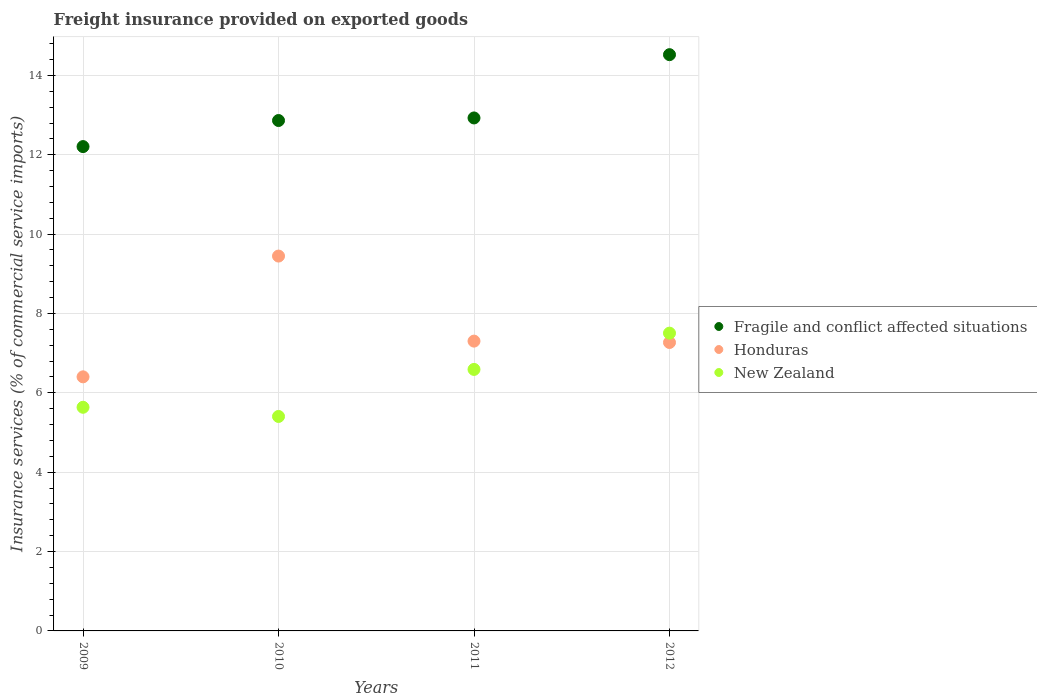Is the number of dotlines equal to the number of legend labels?
Give a very brief answer. Yes. What is the freight insurance provided on exported goods in Fragile and conflict affected situations in 2009?
Your response must be concise. 12.21. Across all years, what is the maximum freight insurance provided on exported goods in Honduras?
Provide a succinct answer. 9.45. Across all years, what is the minimum freight insurance provided on exported goods in New Zealand?
Give a very brief answer. 5.4. In which year was the freight insurance provided on exported goods in Fragile and conflict affected situations minimum?
Make the answer very short. 2009. What is the total freight insurance provided on exported goods in Honduras in the graph?
Your response must be concise. 30.42. What is the difference between the freight insurance provided on exported goods in New Zealand in 2009 and that in 2012?
Your answer should be very brief. -1.87. What is the difference between the freight insurance provided on exported goods in Fragile and conflict affected situations in 2011 and the freight insurance provided on exported goods in Honduras in 2012?
Give a very brief answer. 5.66. What is the average freight insurance provided on exported goods in Fragile and conflict affected situations per year?
Your answer should be very brief. 13.13. In the year 2009, what is the difference between the freight insurance provided on exported goods in New Zealand and freight insurance provided on exported goods in Fragile and conflict affected situations?
Offer a terse response. -6.57. What is the ratio of the freight insurance provided on exported goods in Fragile and conflict affected situations in 2009 to that in 2012?
Your answer should be compact. 0.84. Is the freight insurance provided on exported goods in Honduras in 2009 less than that in 2012?
Provide a short and direct response. Yes. Is the difference between the freight insurance provided on exported goods in New Zealand in 2010 and 2012 greater than the difference between the freight insurance provided on exported goods in Fragile and conflict affected situations in 2010 and 2012?
Offer a terse response. No. What is the difference between the highest and the second highest freight insurance provided on exported goods in Fragile and conflict affected situations?
Keep it short and to the point. 1.59. What is the difference between the highest and the lowest freight insurance provided on exported goods in Fragile and conflict affected situations?
Offer a very short reply. 2.32. Is the sum of the freight insurance provided on exported goods in Honduras in 2010 and 2011 greater than the maximum freight insurance provided on exported goods in Fragile and conflict affected situations across all years?
Your response must be concise. Yes. Does the freight insurance provided on exported goods in New Zealand monotonically increase over the years?
Offer a terse response. No. Is the freight insurance provided on exported goods in New Zealand strictly greater than the freight insurance provided on exported goods in Fragile and conflict affected situations over the years?
Your answer should be compact. No. How many dotlines are there?
Offer a terse response. 3. How many years are there in the graph?
Ensure brevity in your answer.  4. Are the values on the major ticks of Y-axis written in scientific E-notation?
Provide a short and direct response. No. Does the graph contain any zero values?
Give a very brief answer. No. Does the graph contain grids?
Your response must be concise. Yes. Where does the legend appear in the graph?
Your answer should be very brief. Center right. What is the title of the graph?
Offer a terse response. Freight insurance provided on exported goods. Does "Myanmar" appear as one of the legend labels in the graph?
Ensure brevity in your answer.  No. What is the label or title of the X-axis?
Keep it short and to the point. Years. What is the label or title of the Y-axis?
Provide a succinct answer. Insurance services (% of commercial service imports). What is the Insurance services (% of commercial service imports) of Fragile and conflict affected situations in 2009?
Offer a terse response. 12.21. What is the Insurance services (% of commercial service imports) in Honduras in 2009?
Your answer should be very brief. 6.4. What is the Insurance services (% of commercial service imports) of New Zealand in 2009?
Offer a very short reply. 5.64. What is the Insurance services (% of commercial service imports) in Fragile and conflict affected situations in 2010?
Your answer should be compact. 12.86. What is the Insurance services (% of commercial service imports) of Honduras in 2010?
Provide a succinct answer. 9.45. What is the Insurance services (% of commercial service imports) of New Zealand in 2010?
Your answer should be very brief. 5.4. What is the Insurance services (% of commercial service imports) in Fragile and conflict affected situations in 2011?
Your answer should be very brief. 12.93. What is the Insurance services (% of commercial service imports) in Honduras in 2011?
Offer a terse response. 7.3. What is the Insurance services (% of commercial service imports) in New Zealand in 2011?
Provide a short and direct response. 6.59. What is the Insurance services (% of commercial service imports) of Fragile and conflict affected situations in 2012?
Your answer should be compact. 14.52. What is the Insurance services (% of commercial service imports) in Honduras in 2012?
Keep it short and to the point. 7.27. What is the Insurance services (% of commercial service imports) of New Zealand in 2012?
Give a very brief answer. 7.5. Across all years, what is the maximum Insurance services (% of commercial service imports) of Fragile and conflict affected situations?
Your answer should be very brief. 14.52. Across all years, what is the maximum Insurance services (% of commercial service imports) in Honduras?
Make the answer very short. 9.45. Across all years, what is the maximum Insurance services (% of commercial service imports) of New Zealand?
Provide a short and direct response. 7.5. Across all years, what is the minimum Insurance services (% of commercial service imports) in Fragile and conflict affected situations?
Provide a short and direct response. 12.21. Across all years, what is the minimum Insurance services (% of commercial service imports) in Honduras?
Ensure brevity in your answer.  6.4. Across all years, what is the minimum Insurance services (% of commercial service imports) in New Zealand?
Your answer should be compact. 5.4. What is the total Insurance services (% of commercial service imports) in Fragile and conflict affected situations in the graph?
Give a very brief answer. 52.52. What is the total Insurance services (% of commercial service imports) in Honduras in the graph?
Provide a short and direct response. 30.42. What is the total Insurance services (% of commercial service imports) in New Zealand in the graph?
Provide a short and direct response. 25.14. What is the difference between the Insurance services (% of commercial service imports) in Fragile and conflict affected situations in 2009 and that in 2010?
Your answer should be compact. -0.66. What is the difference between the Insurance services (% of commercial service imports) in Honduras in 2009 and that in 2010?
Give a very brief answer. -3.04. What is the difference between the Insurance services (% of commercial service imports) in New Zealand in 2009 and that in 2010?
Your response must be concise. 0.23. What is the difference between the Insurance services (% of commercial service imports) in Fragile and conflict affected situations in 2009 and that in 2011?
Ensure brevity in your answer.  -0.72. What is the difference between the Insurance services (% of commercial service imports) of Honduras in 2009 and that in 2011?
Keep it short and to the point. -0.9. What is the difference between the Insurance services (% of commercial service imports) of New Zealand in 2009 and that in 2011?
Make the answer very short. -0.95. What is the difference between the Insurance services (% of commercial service imports) in Fragile and conflict affected situations in 2009 and that in 2012?
Offer a terse response. -2.32. What is the difference between the Insurance services (% of commercial service imports) in Honduras in 2009 and that in 2012?
Offer a terse response. -0.87. What is the difference between the Insurance services (% of commercial service imports) of New Zealand in 2009 and that in 2012?
Offer a very short reply. -1.87. What is the difference between the Insurance services (% of commercial service imports) in Fragile and conflict affected situations in 2010 and that in 2011?
Give a very brief answer. -0.06. What is the difference between the Insurance services (% of commercial service imports) in Honduras in 2010 and that in 2011?
Keep it short and to the point. 2.14. What is the difference between the Insurance services (% of commercial service imports) in New Zealand in 2010 and that in 2011?
Offer a very short reply. -1.19. What is the difference between the Insurance services (% of commercial service imports) in Fragile and conflict affected situations in 2010 and that in 2012?
Your response must be concise. -1.66. What is the difference between the Insurance services (% of commercial service imports) of Honduras in 2010 and that in 2012?
Make the answer very short. 2.18. What is the difference between the Insurance services (% of commercial service imports) in New Zealand in 2010 and that in 2012?
Ensure brevity in your answer.  -2.1. What is the difference between the Insurance services (% of commercial service imports) of Fragile and conflict affected situations in 2011 and that in 2012?
Make the answer very short. -1.59. What is the difference between the Insurance services (% of commercial service imports) in Honduras in 2011 and that in 2012?
Offer a terse response. 0.03. What is the difference between the Insurance services (% of commercial service imports) of New Zealand in 2011 and that in 2012?
Your response must be concise. -0.91. What is the difference between the Insurance services (% of commercial service imports) of Fragile and conflict affected situations in 2009 and the Insurance services (% of commercial service imports) of Honduras in 2010?
Your answer should be very brief. 2.76. What is the difference between the Insurance services (% of commercial service imports) of Fragile and conflict affected situations in 2009 and the Insurance services (% of commercial service imports) of New Zealand in 2010?
Offer a very short reply. 6.8. What is the difference between the Insurance services (% of commercial service imports) in Honduras in 2009 and the Insurance services (% of commercial service imports) in New Zealand in 2010?
Ensure brevity in your answer.  1. What is the difference between the Insurance services (% of commercial service imports) of Fragile and conflict affected situations in 2009 and the Insurance services (% of commercial service imports) of Honduras in 2011?
Keep it short and to the point. 4.9. What is the difference between the Insurance services (% of commercial service imports) of Fragile and conflict affected situations in 2009 and the Insurance services (% of commercial service imports) of New Zealand in 2011?
Ensure brevity in your answer.  5.62. What is the difference between the Insurance services (% of commercial service imports) of Honduras in 2009 and the Insurance services (% of commercial service imports) of New Zealand in 2011?
Offer a very short reply. -0.19. What is the difference between the Insurance services (% of commercial service imports) in Fragile and conflict affected situations in 2009 and the Insurance services (% of commercial service imports) in Honduras in 2012?
Give a very brief answer. 4.94. What is the difference between the Insurance services (% of commercial service imports) in Fragile and conflict affected situations in 2009 and the Insurance services (% of commercial service imports) in New Zealand in 2012?
Provide a short and direct response. 4.7. What is the difference between the Insurance services (% of commercial service imports) in Honduras in 2009 and the Insurance services (% of commercial service imports) in New Zealand in 2012?
Keep it short and to the point. -1.1. What is the difference between the Insurance services (% of commercial service imports) in Fragile and conflict affected situations in 2010 and the Insurance services (% of commercial service imports) in Honduras in 2011?
Provide a short and direct response. 5.56. What is the difference between the Insurance services (% of commercial service imports) of Fragile and conflict affected situations in 2010 and the Insurance services (% of commercial service imports) of New Zealand in 2011?
Provide a succinct answer. 6.27. What is the difference between the Insurance services (% of commercial service imports) of Honduras in 2010 and the Insurance services (% of commercial service imports) of New Zealand in 2011?
Ensure brevity in your answer.  2.86. What is the difference between the Insurance services (% of commercial service imports) in Fragile and conflict affected situations in 2010 and the Insurance services (% of commercial service imports) in Honduras in 2012?
Make the answer very short. 5.59. What is the difference between the Insurance services (% of commercial service imports) of Fragile and conflict affected situations in 2010 and the Insurance services (% of commercial service imports) of New Zealand in 2012?
Give a very brief answer. 5.36. What is the difference between the Insurance services (% of commercial service imports) in Honduras in 2010 and the Insurance services (% of commercial service imports) in New Zealand in 2012?
Your response must be concise. 1.94. What is the difference between the Insurance services (% of commercial service imports) of Fragile and conflict affected situations in 2011 and the Insurance services (% of commercial service imports) of Honduras in 2012?
Keep it short and to the point. 5.66. What is the difference between the Insurance services (% of commercial service imports) in Fragile and conflict affected situations in 2011 and the Insurance services (% of commercial service imports) in New Zealand in 2012?
Your answer should be compact. 5.42. What is the difference between the Insurance services (% of commercial service imports) in Honduras in 2011 and the Insurance services (% of commercial service imports) in New Zealand in 2012?
Your response must be concise. -0.2. What is the average Insurance services (% of commercial service imports) in Fragile and conflict affected situations per year?
Offer a terse response. 13.13. What is the average Insurance services (% of commercial service imports) of Honduras per year?
Make the answer very short. 7.61. What is the average Insurance services (% of commercial service imports) of New Zealand per year?
Your answer should be very brief. 6.28. In the year 2009, what is the difference between the Insurance services (% of commercial service imports) of Fragile and conflict affected situations and Insurance services (% of commercial service imports) of Honduras?
Give a very brief answer. 5.8. In the year 2009, what is the difference between the Insurance services (% of commercial service imports) of Fragile and conflict affected situations and Insurance services (% of commercial service imports) of New Zealand?
Provide a short and direct response. 6.57. In the year 2009, what is the difference between the Insurance services (% of commercial service imports) in Honduras and Insurance services (% of commercial service imports) in New Zealand?
Your answer should be compact. 0.77. In the year 2010, what is the difference between the Insurance services (% of commercial service imports) in Fragile and conflict affected situations and Insurance services (% of commercial service imports) in Honduras?
Offer a terse response. 3.42. In the year 2010, what is the difference between the Insurance services (% of commercial service imports) of Fragile and conflict affected situations and Insurance services (% of commercial service imports) of New Zealand?
Give a very brief answer. 7.46. In the year 2010, what is the difference between the Insurance services (% of commercial service imports) in Honduras and Insurance services (% of commercial service imports) in New Zealand?
Your response must be concise. 4.04. In the year 2011, what is the difference between the Insurance services (% of commercial service imports) of Fragile and conflict affected situations and Insurance services (% of commercial service imports) of Honduras?
Give a very brief answer. 5.62. In the year 2011, what is the difference between the Insurance services (% of commercial service imports) of Fragile and conflict affected situations and Insurance services (% of commercial service imports) of New Zealand?
Your answer should be very brief. 6.34. In the year 2011, what is the difference between the Insurance services (% of commercial service imports) in Honduras and Insurance services (% of commercial service imports) in New Zealand?
Keep it short and to the point. 0.71. In the year 2012, what is the difference between the Insurance services (% of commercial service imports) in Fragile and conflict affected situations and Insurance services (% of commercial service imports) in Honduras?
Provide a short and direct response. 7.25. In the year 2012, what is the difference between the Insurance services (% of commercial service imports) of Fragile and conflict affected situations and Insurance services (% of commercial service imports) of New Zealand?
Your answer should be very brief. 7.02. In the year 2012, what is the difference between the Insurance services (% of commercial service imports) in Honduras and Insurance services (% of commercial service imports) in New Zealand?
Ensure brevity in your answer.  -0.24. What is the ratio of the Insurance services (% of commercial service imports) of Fragile and conflict affected situations in 2009 to that in 2010?
Ensure brevity in your answer.  0.95. What is the ratio of the Insurance services (% of commercial service imports) of Honduras in 2009 to that in 2010?
Provide a short and direct response. 0.68. What is the ratio of the Insurance services (% of commercial service imports) of New Zealand in 2009 to that in 2010?
Offer a very short reply. 1.04. What is the ratio of the Insurance services (% of commercial service imports) of Fragile and conflict affected situations in 2009 to that in 2011?
Provide a succinct answer. 0.94. What is the ratio of the Insurance services (% of commercial service imports) in Honduras in 2009 to that in 2011?
Provide a short and direct response. 0.88. What is the ratio of the Insurance services (% of commercial service imports) in New Zealand in 2009 to that in 2011?
Keep it short and to the point. 0.86. What is the ratio of the Insurance services (% of commercial service imports) of Fragile and conflict affected situations in 2009 to that in 2012?
Offer a very short reply. 0.84. What is the ratio of the Insurance services (% of commercial service imports) of Honduras in 2009 to that in 2012?
Your answer should be very brief. 0.88. What is the ratio of the Insurance services (% of commercial service imports) of New Zealand in 2009 to that in 2012?
Your answer should be very brief. 0.75. What is the ratio of the Insurance services (% of commercial service imports) of Honduras in 2010 to that in 2011?
Your answer should be very brief. 1.29. What is the ratio of the Insurance services (% of commercial service imports) of New Zealand in 2010 to that in 2011?
Your answer should be very brief. 0.82. What is the ratio of the Insurance services (% of commercial service imports) in Fragile and conflict affected situations in 2010 to that in 2012?
Your answer should be compact. 0.89. What is the ratio of the Insurance services (% of commercial service imports) in Honduras in 2010 to that in 2012?
Your answer should be compact. 1.3. What is the ratio of the Insurance services (% of commercial service imports) of New Zealand in 2010 to that in 2012?
Give a very brief answer. 0.72. What is the ratio of the Insurance services (% of commercial service imports) of Fragile and conflict affected situations in 2011 to that in 2012?
Provide a short and direct response. 0.89. What is the ratio of the Insurance services (% of commercial service imports) of Honduras in 2011 to that in 2012?
Offer a very short reply. 1. What is the ratio of the Insurance services (% of commercial service imports) in New Zealand in 2011 to that in 2012?
Give a very brief answer. 0.88. What is the difference between the highest and the second highest Insurance services (% of commercial service imports) in Fragile and conflict affected situations?
Make the answer very short. 1.59. What is the difference between the highest and the second highest Insurance services (% of commercial service imports) in Honduras?
Provide a succinct answer. 2.14. What is the difference between the highest and the second highest Insurance services (% of commercial service imports) in New Zealand?
Keep it short and to the point. 0.91. What is the difference between the highest and the lowest Insurance services (% of commercial service imports) of Fragile and conflict affected situations?
Your response must be concise. 2.32. What is the difference between the highest and the lowest Insurance services (% of commercial service imports) of Honduras?
Offer a terse response. 3.04. What is the difference between the highest and the lowest Insurance services (% of commercial service imports) of New Zealand?
Provide a succinct answer. 2.1. 